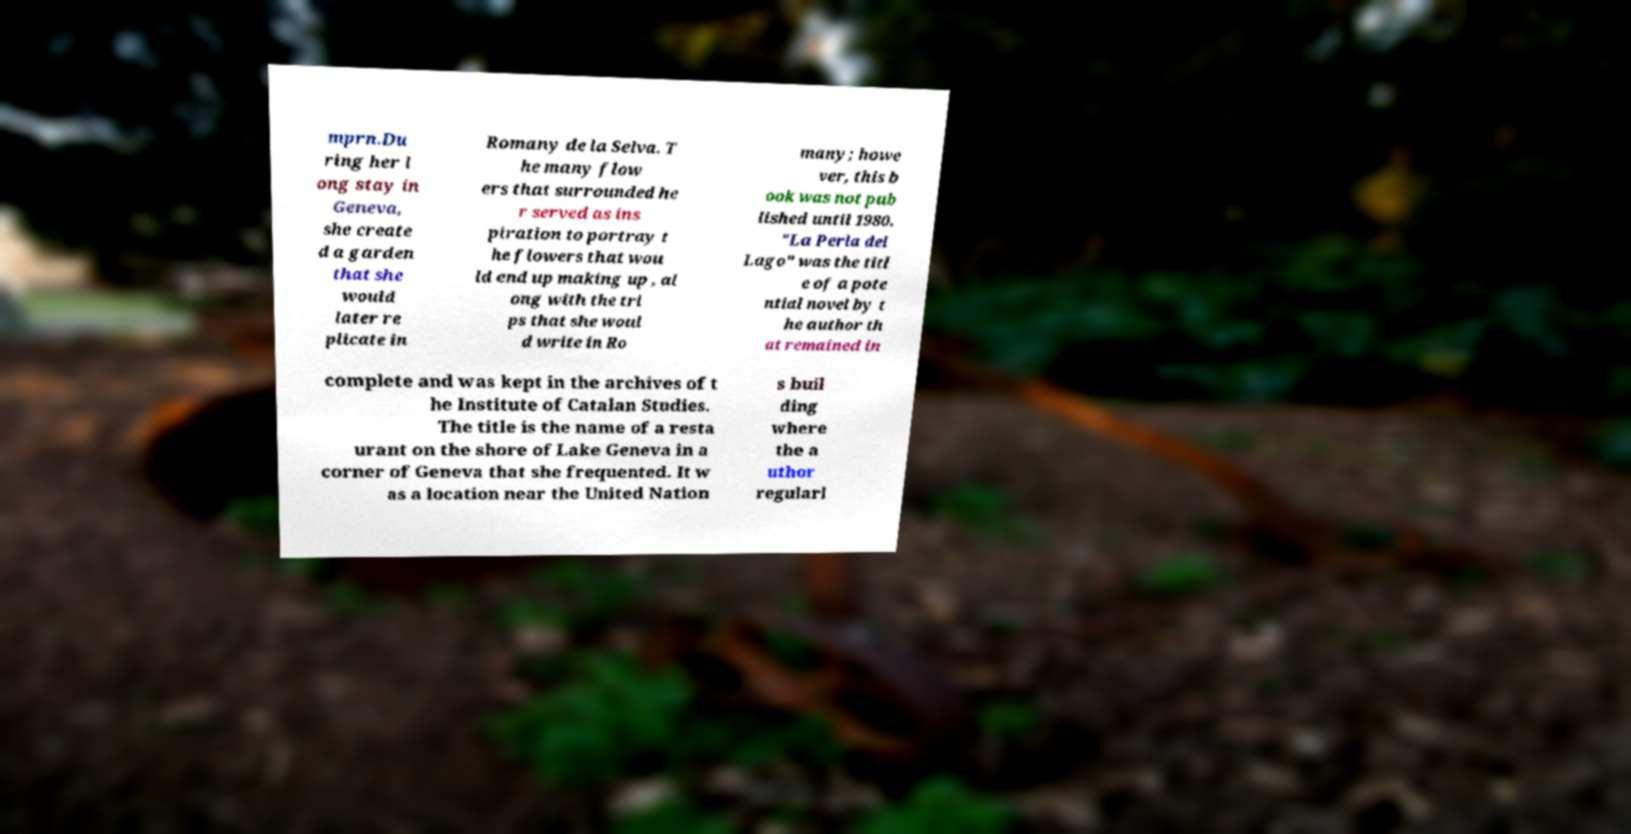Could you extract and type out the text from this image? mprn.Du ring her l ong stay in Geneva, she create d a garden that she would later re plicate in Romany de la Selva. T he many flow ers that surrounded he r served as ins piration to portray t he flowers that wou ld end up making up , al ong with the tri ps that she woul d write in Ro many; howe ver, this b ook was not pub lished until 1980. "La Perla del Lago" was the titl e of a pote ntial novel by t he author th at remained in complete and was kept in the archives of t he Institute of Catalan Studies. The title is the name of a resta urant on the shore of Lake Geneva in a corner of Geneva that she frequented. It w as a location near the United Nation s buil ding where the a uthor regularl 